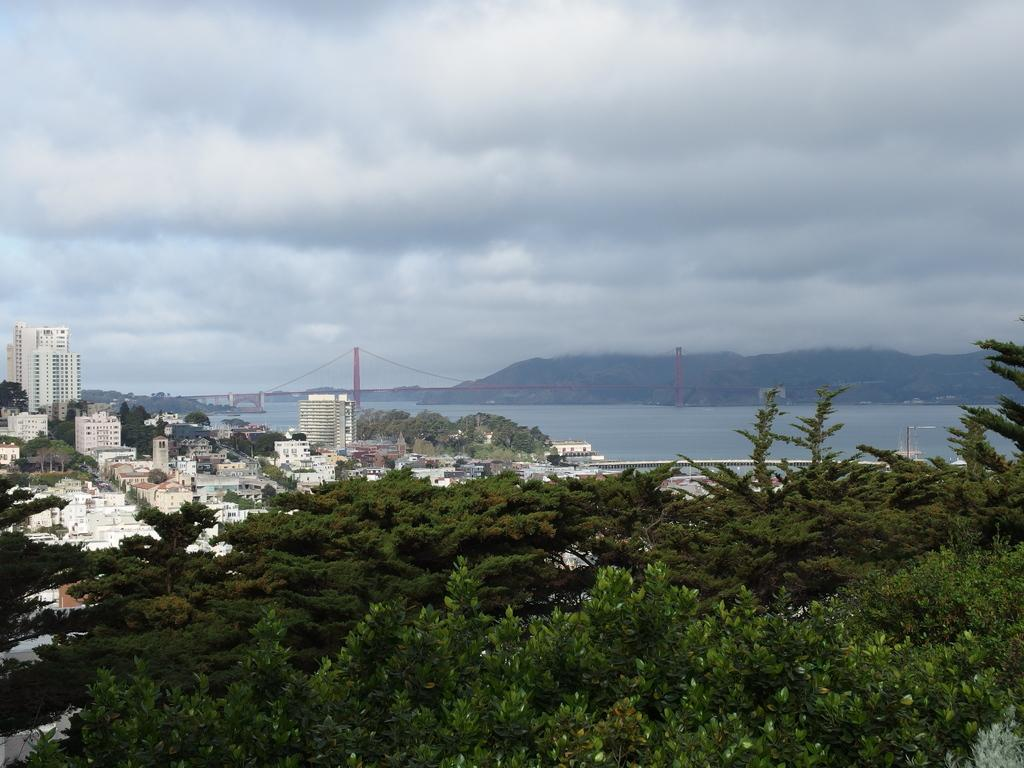What type of vegetation can be seen in the image? There are trees in the image. What is the color of the trees? The trees are green in color. What structures are present in the image? There are buildings in the image. What type of pathway is visible in the image? There is a road in the image. What architectural feature can be seen in the background of the image? There is a bridge in the background of the image. What natural feature is visible in the background of the image? There is water and a mountain visible in the background of the image. What part of the natural environment is visible in the background of the image? The sky is visible in the background of the image. How many cows are grazing on the mountain in the image? There are no cows present in the image; it features trees, buildings, a road, a bridge, water, a mountain, and the sky. What type of planes can be seen flying over the bridge in the image? There are no planes visible in the image. 